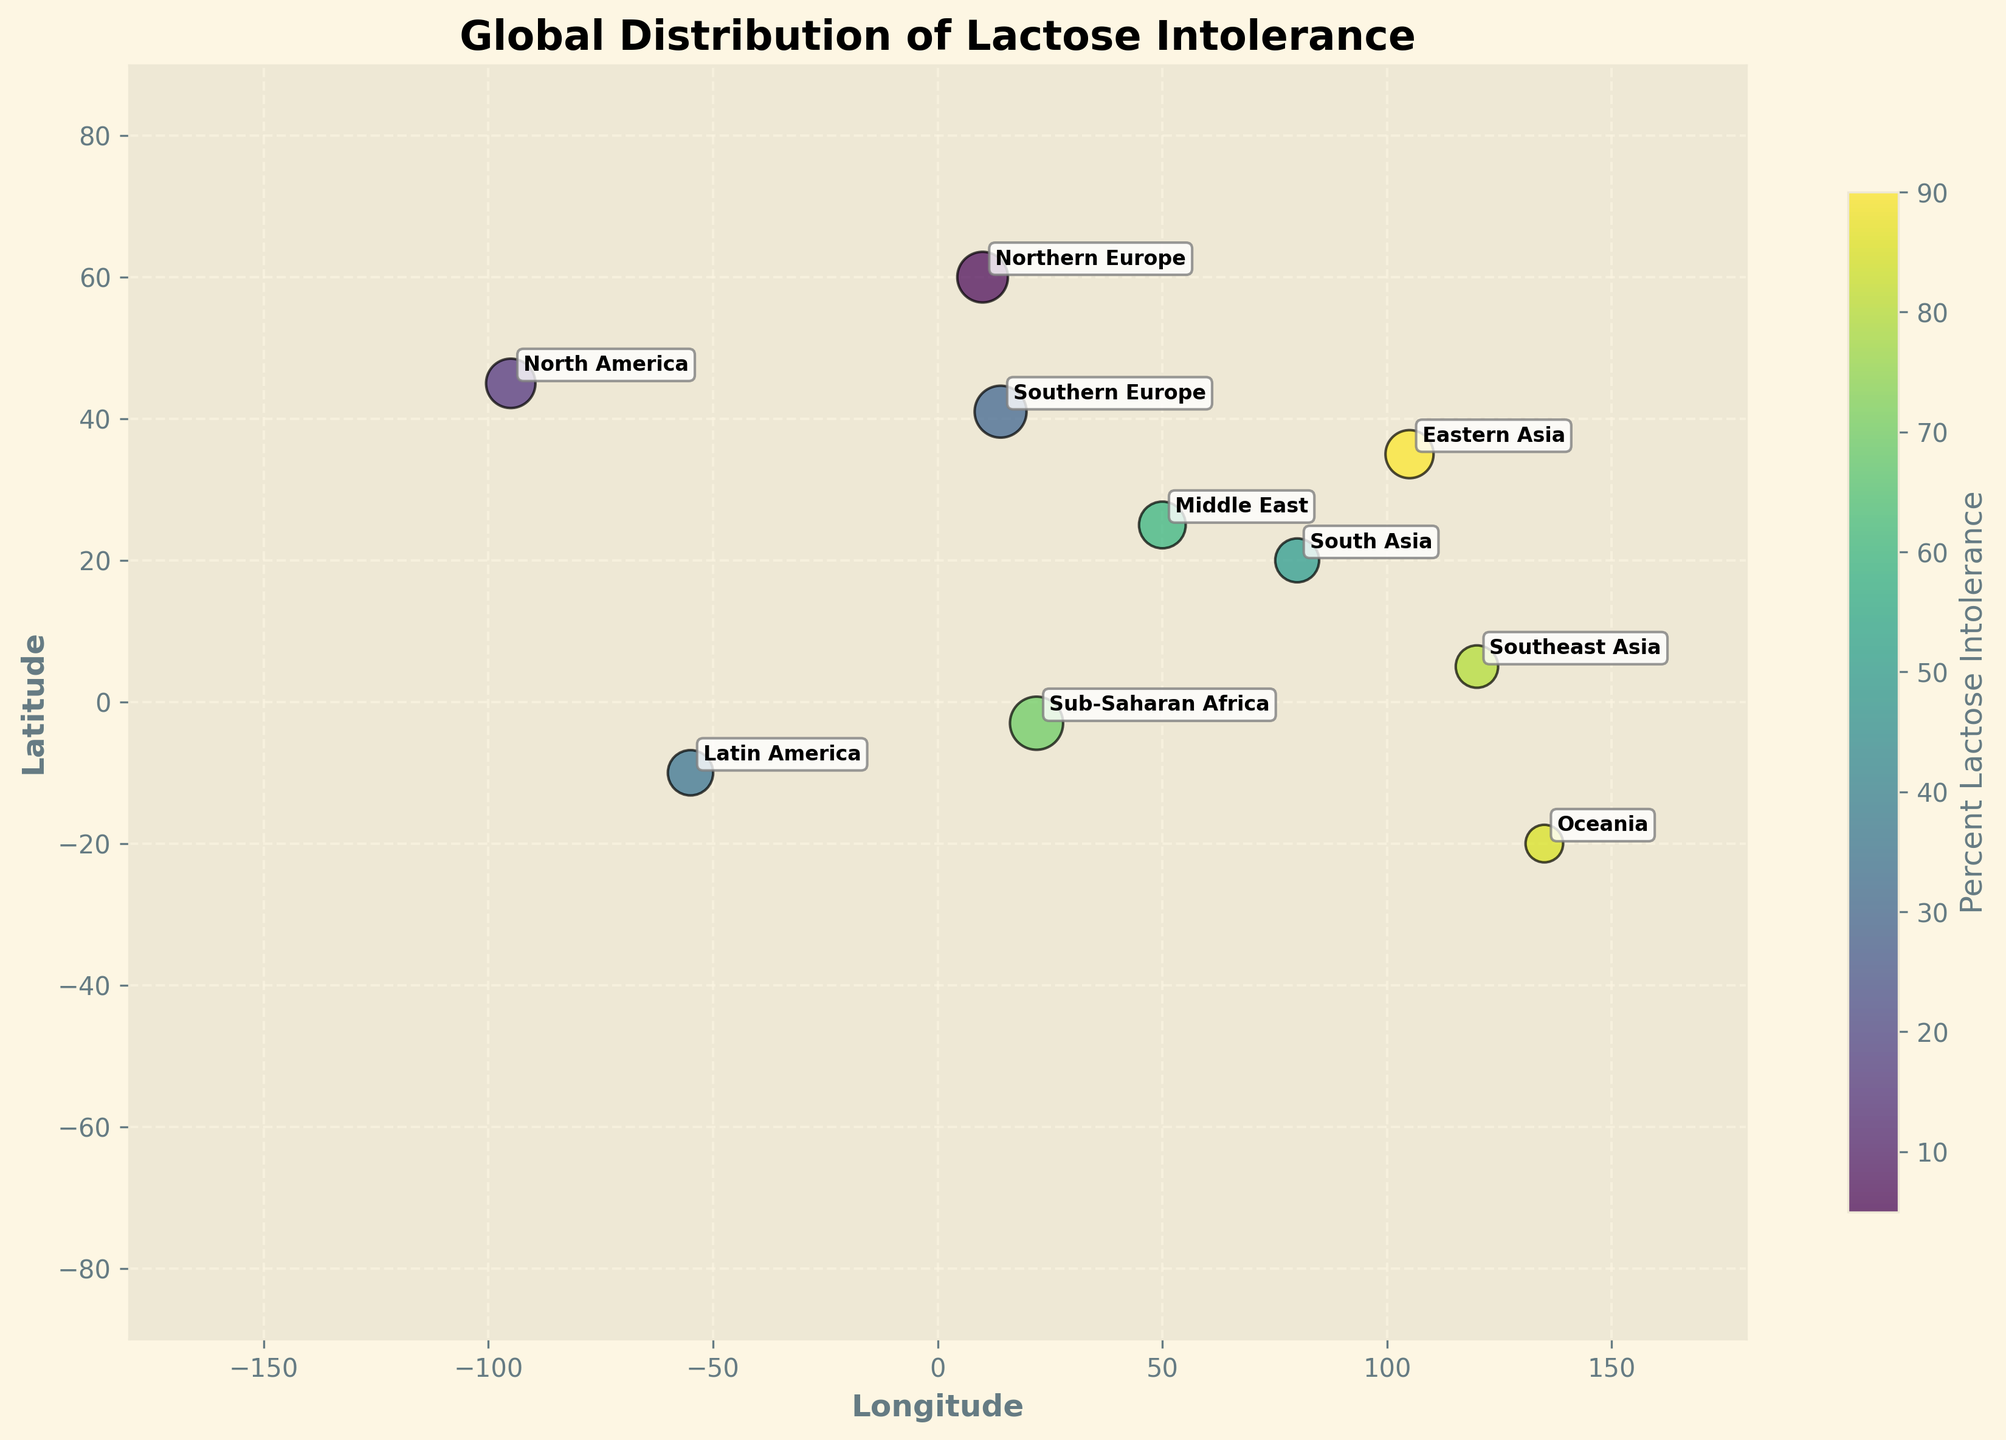How many different populations are represented on the bubble chart? The bubble chart annotates each population with its name. By counting all the unique annotations, we can determine the number of distinct populations represented on the chart.
Answer: 10 Which population has the highest percentage of lactose intolerance? The color intensity of the bubbles represents the percentage of lactose intolerance within each population. The bubble with the darkest color would indicate the highest percentage. The label next to this bubble identifies the population.
Answer: Oceania What is the sample size of the Northern European population? The size of the bubbles reflects the sample size. By locating the bubble annotated with "Northern Europe" and checking its size or directly referring to the provided data, we can find the sample size.
Answer: 200 Which population has the smallest bubble, indicating the smallest sample size? The bubble size reflects the sample size. Finding the smallest bubble and referring to its label would identify the population with the smallest sample size.
Answer: Oceania Compare the percentage of lactose intolerance between Northern Europe and Eastern Asia. Which one is greater and by how much? The color intensity indicates the percentage of lactose intolerance. Northern Europe's color is much lighter compared to the darker color of Eastern Asia. Referring to the provided data, Northern Europe has 5% and Eastern Asia has 90%. The difference is 90% - 5% = 85%.
Answer: Eastern Asia by 85% Which populations have a lactose intolerance percentage greater than 50%? Referring to the color intensity on the chart, the populations with darker bubbles have a higher percentage. Using the data, identify the ones with a percentage greater than 50%.
Answer: Eastern Asia, Sub-Saharan Africa, Southeast Asia, Oceania What is the relationship between sample size and percentage of lactose intolerance for Sub-Saharan Africa? Examine the bubble for Sub-Saharan Africa in the chart. Larger bubbles indicate larger sample sizes. Sub-Saharan Africa’s bubble is large and dark, indicating a large sample size and a high percentage of lactose intolerance.
Answer: Large sample size, high lactose intolerance Which region has almost equal lactose intolerance percentages but different sample sizes? Examine bubbles with similar color intensity but different sizes. Cross-referencing with the data, we can find populations with closely matched percentages but differing in sample sizes.
Answer: Sub-Saharan Africa (70%, 220) and Middle East (60%, 170) How does latitude seem to correlate with lactose intolerance percentage based on this chart? Observe the latitude positions on the y-axis and the color intensity of the bubbles along those points. Generally, higher latitudes (towards the poles) tend to have lighter bubbles indicating lower intolerance, while lower latitudes (closer to the equator) have darker bubbles.
Answer: Higher latitudes lower intolerance, lower latitudes higher intolerance What is the geographical distribution pattern for populations with less than 20% lactose intolerance? Locate the lightest-colored bubbles, and see their annotated positions on the map. The populations with less than 20% are Northern Europe and North America. They are both situated in higher northern latitudes.
Answer: Higher northern latitudes 